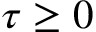Convert formula to latex. <formula><loc_0><loc_0><loc_500><loc_500>\tau \geq 0</formula> 